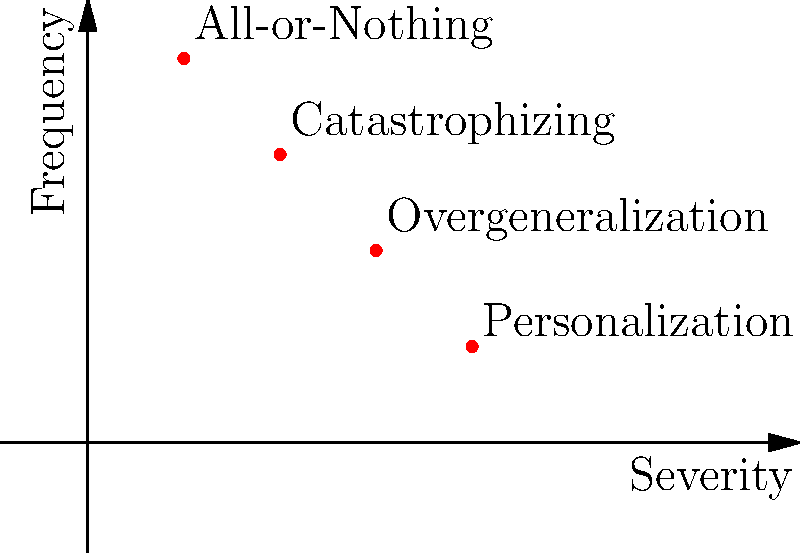In the given 2D vector space representing cognitive distortions, where the x-axis represents severity and the y-axis represents frequency, which cognitive distortion is represented by the vector with the highest severity but lowest frequency? To answer this question, we need to analyze the positions of the cognitive distortions in the 2D space:

1. First, identify the axes:
   - X-axis represents severity (increasing from left to right)
   - Y-axis represents frequency (increasing from bottom to top)

2. Locate each cognitive distortion:
   - All-or-Nothing: (1,4)
   - Overgeneralization: (3,2)
   - Catastrophizing: (2,3)
   - Personalization: (4,1)

3. We're looking for the highest severity (furthest right on x-axis) and lowest frequency (lowest on y-axis).

4. Comparing the x-coordinates (severity):
   Personalization (4) > Overgeneralization (3) > Catastrophizing (2) > All-or-Nothing (1)

5. Comparing the y-coordinates (frequency):
   All-or-Nothing (4) > Catastrophizing (3) > Overgeneralization (2) > Personalization (1)

6. Personalization has both the highest severity (4) and the lowest frequency (1).

Therefore, Personalization is the cognitive distortion represented by the vector with the highest severity but lowest frequency.
Answer: Personalization 